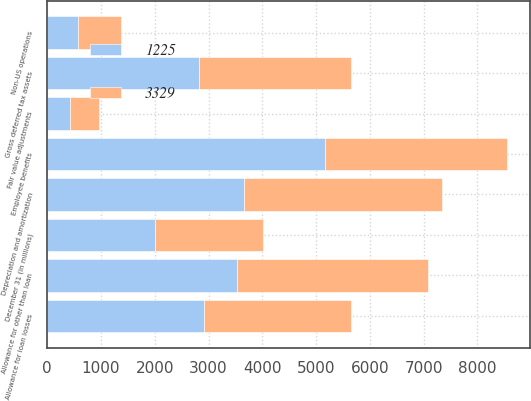Convert chart. <chart><loc_0><loc_0><loc_500><loc_500><stacked_bar_chart><ecel><fcel>December 31 (in millions)<fcel>Employee benefits<fcel>Allowance for other than loan<fcel>Allowance for loan losses<fcel>Non-US operations<fcel>Fair value adjustments<fcel>Gross deferred tax assets<fcel>Depreciation and amortization<nl><fcel>1225<fcel>2006<fcel>5175<fcel>3533<fcel>2910<fcel>566<fcel>427<fcel>2827.5<fcel>3668<nl><fcel>3329<fcel>2005<fcel>3381<fcel>3554<fcel>2745<fcel>807<fcel>531<fcel>2827.5<fcel>3683<nl></chart> 